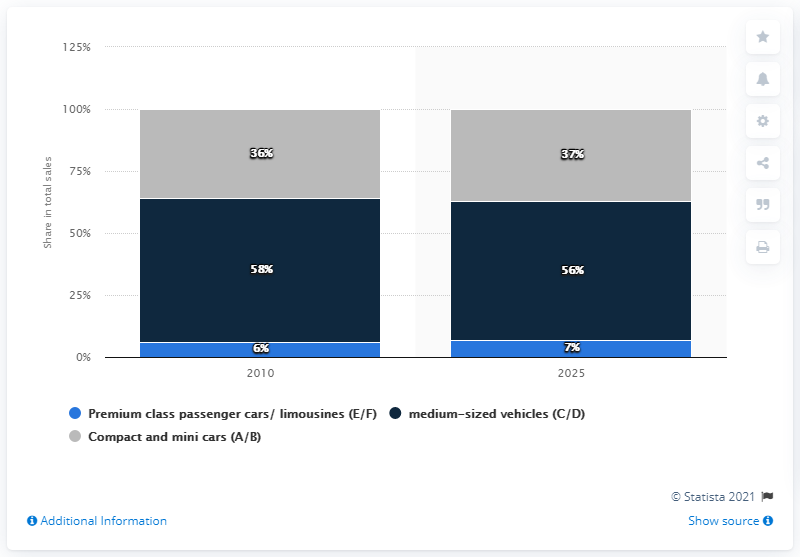Highlight a few significant elements in this photo. By the year 2025, it is projected that the share of automobile sales in China will increase. In 2010, premium class automobiles and limousines generated approximately 6% of total sales in China. 